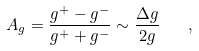Convert formula to latex. <formula><loc_0><loc_0><loc_500><loc_500>A _ { g } = \frac { g ^ { + } - g ^ { - } } { g ^ { + } + g ^ { - } } \sim \frac { \Delta g } { 2 g } \quad ,</formula> 